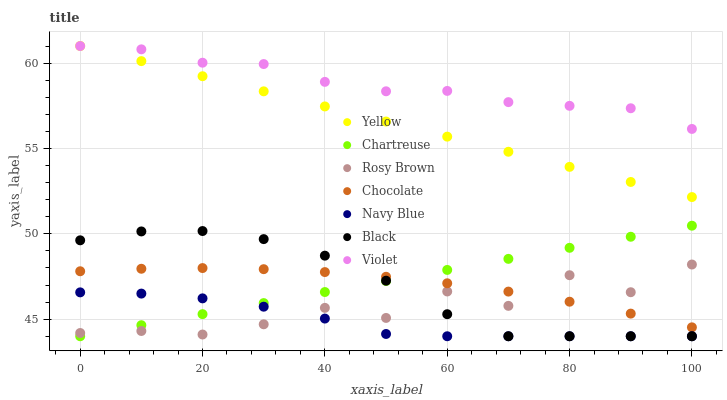Does Navy Blue have the minimum area under the curve?
Answer yes or no. Yes. Does Violet have the maximum area under the curve?
Answer yes or no. Yes. Does Rosy Brown have the minimum area under the curve?
Answer yes or no. No. Does Rosy Brown have the maximum area under the curve?
Answer yes or no. No. Is Yellow the smoothest?
Answer yes or no. Yes. Is Rosy Brown the roughest?
Answer yes or no. Yes. Is Rosy Brown the smoothest?
Answer yes or no. No. Is Yellow the roughest?
Answer yes or no. No. Does Navy Blue have the lowest value?
Answer yes or no. Yes. Does Rosy Brown have the lowest value?
Answer yes or no. No. Does Violet have the highest value?
Answer yes or no. Yes. Does Rosy Brown have the highest value?
Answer yes or no. No. Is Black less than Violet?
Answer yes or no. Yes. Is Yellow greater than Black?
Answer yes or no. Yes. Does Chocolate intersect Rosy Brown?
Answer yes or no. Yes. Is Chocolate less than Rosy Brown?
Answer yes or no. No. Is Chocolate greater than Rosy Brown?
Answer yes or no. No. Does Black intersect Violet?
Answer yes or no. No. 